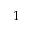<formula> <loc_0><loc_0><loc_500><loc_500>1</formula> 